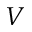Convert formula to latex. <formula><loc_0><loc_0><loc_500><loc_500>V</formula> 